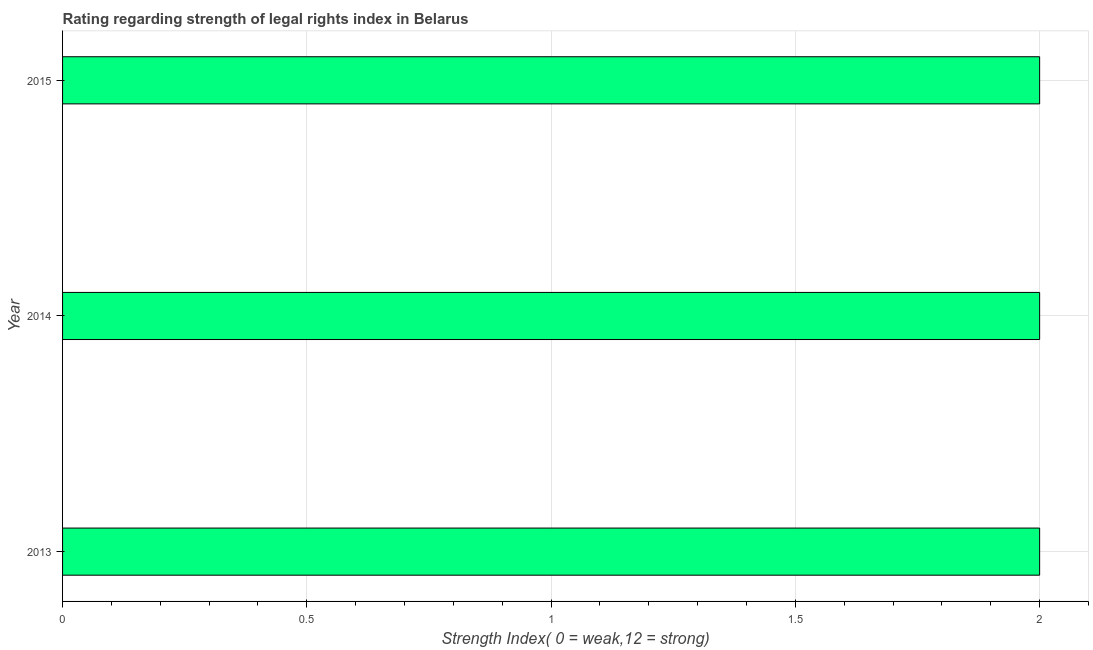Does the graph contain any zero values?
Offer a very short reply. No. Does the graph contain grids?
Your answer should be compact. Yes. What is the title of the graph?
Ensure brevity in your answer.  Rating regarding strength of legal rights index in Belarus. What is the label or title of the X-axis?
Give a very brief answer. Strength Index( 0 = weak,12 = strong). What is the label or title of the Y-axis?
Make the answer very short. Year. Across all years, what is the maximum strength of legal rights index?
Give a very brief answer. 2. Across all years, what is the minimum strength of legal rights index?
Give a very brief answer. 2. In which year was the strength of legal rights index maximum?
Your response must be concise. 2013. In which year was the strength of legal rights index minimum?
Give a very brief answer. 2013. In how many years, is the strength of legal rights index greater than 1.7 ?
Keep it short and to the point. 3. Is the strength of legal rights index in 2014 less than that in 2015?
Your response must be concise. No. Is the difference between the strength of legal rights index in 2013 and 2015 greater than the difference between any two years?
Offer a terse response. Yes. What is the difference between the highest and the second highest strength of legal rights index?
Keep it short and to the point. 0. Is the sum of the strength of legal rights index in 2014 and 2015 greater than the maximum strength of legal rights index across all years?
Provide a short and direct response. Yes. What is the difference between the highest and the lowest strength of legal rights index?
Give a very brief answer. 0. How many bars are there?
Keep it short and to the point. 3. What is the difference between two consecutive major ticks on the X-axis?
Offer a terse response. 0.5. Are the values on the major ticks of X-axis written in scientific E-notation?
Ensure brevity in your answer.  No. What is the Strength Index( 0 = weak,12 = strong) in 2013?
Your answer should be very brief. 2. What is the Strength Index( 0 = weak,12 = strong) in 2014?
Keep it short and to the point. 2. What is the difference between the Strength Index( 0 = weak,12 = strong) in 2013 and 2014?
Keep it short and to the point. 0. What is the difference between the Strength Index( 0 = weak,12 = strong) in 2014 and 2015?
Your answer should be very brief. 0. What is the ratio of the Strength Index( 0 = weak,12 = strong) in 2013 to that in 2015?
Provide a short and direct response. 1. What is the ratio of the Strength Index( 0 = weak,12 = strong) in 2014 to that in 2015?
Your answer should be very brief. 1. 